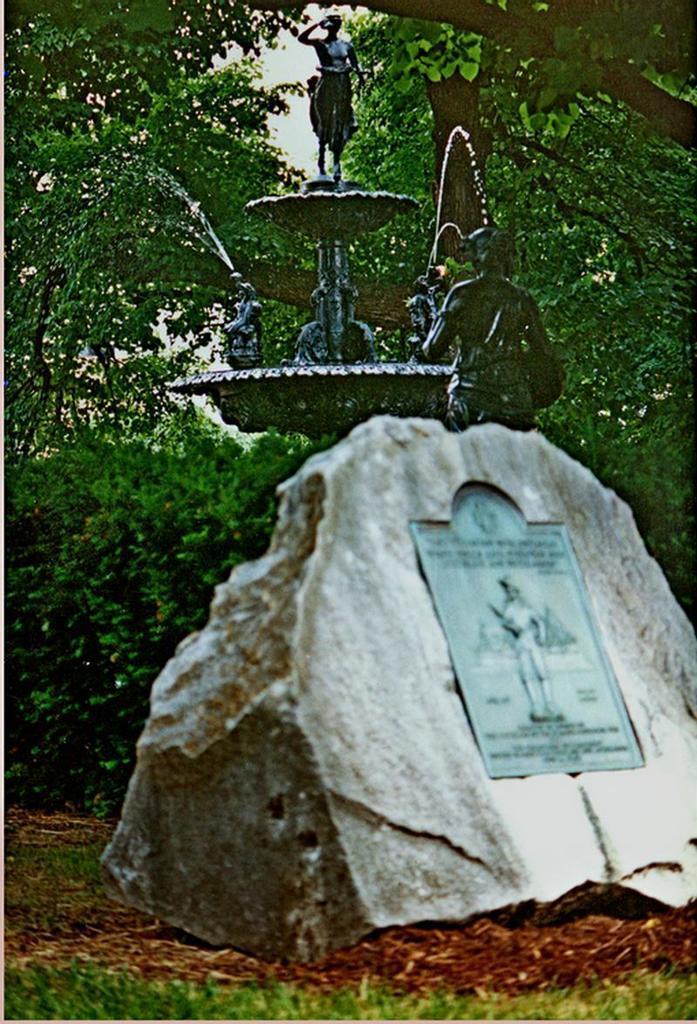Could you give a brief overview of what you see in this image? In this image there is a rock. On the rock there is a silver board with an image and some text, behind the rock there is a fountain. In the background there are trees, there are dry leaves and grass on the surface. 